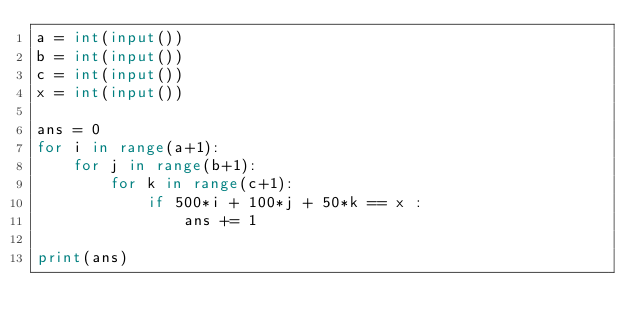Convert code to text. <code><loc_0><loc_0><loc_500><loc_500><_Python_>a = int(input())
b = int(input())
c = int(input())
x = int(input())

ans = 0
for i in range(a+1):
    for j in range(b+1):
        for k in range(c+1):
            if 500*i + 100*j + 50*k == x :
                ans += 1

print(ans)
</code> 